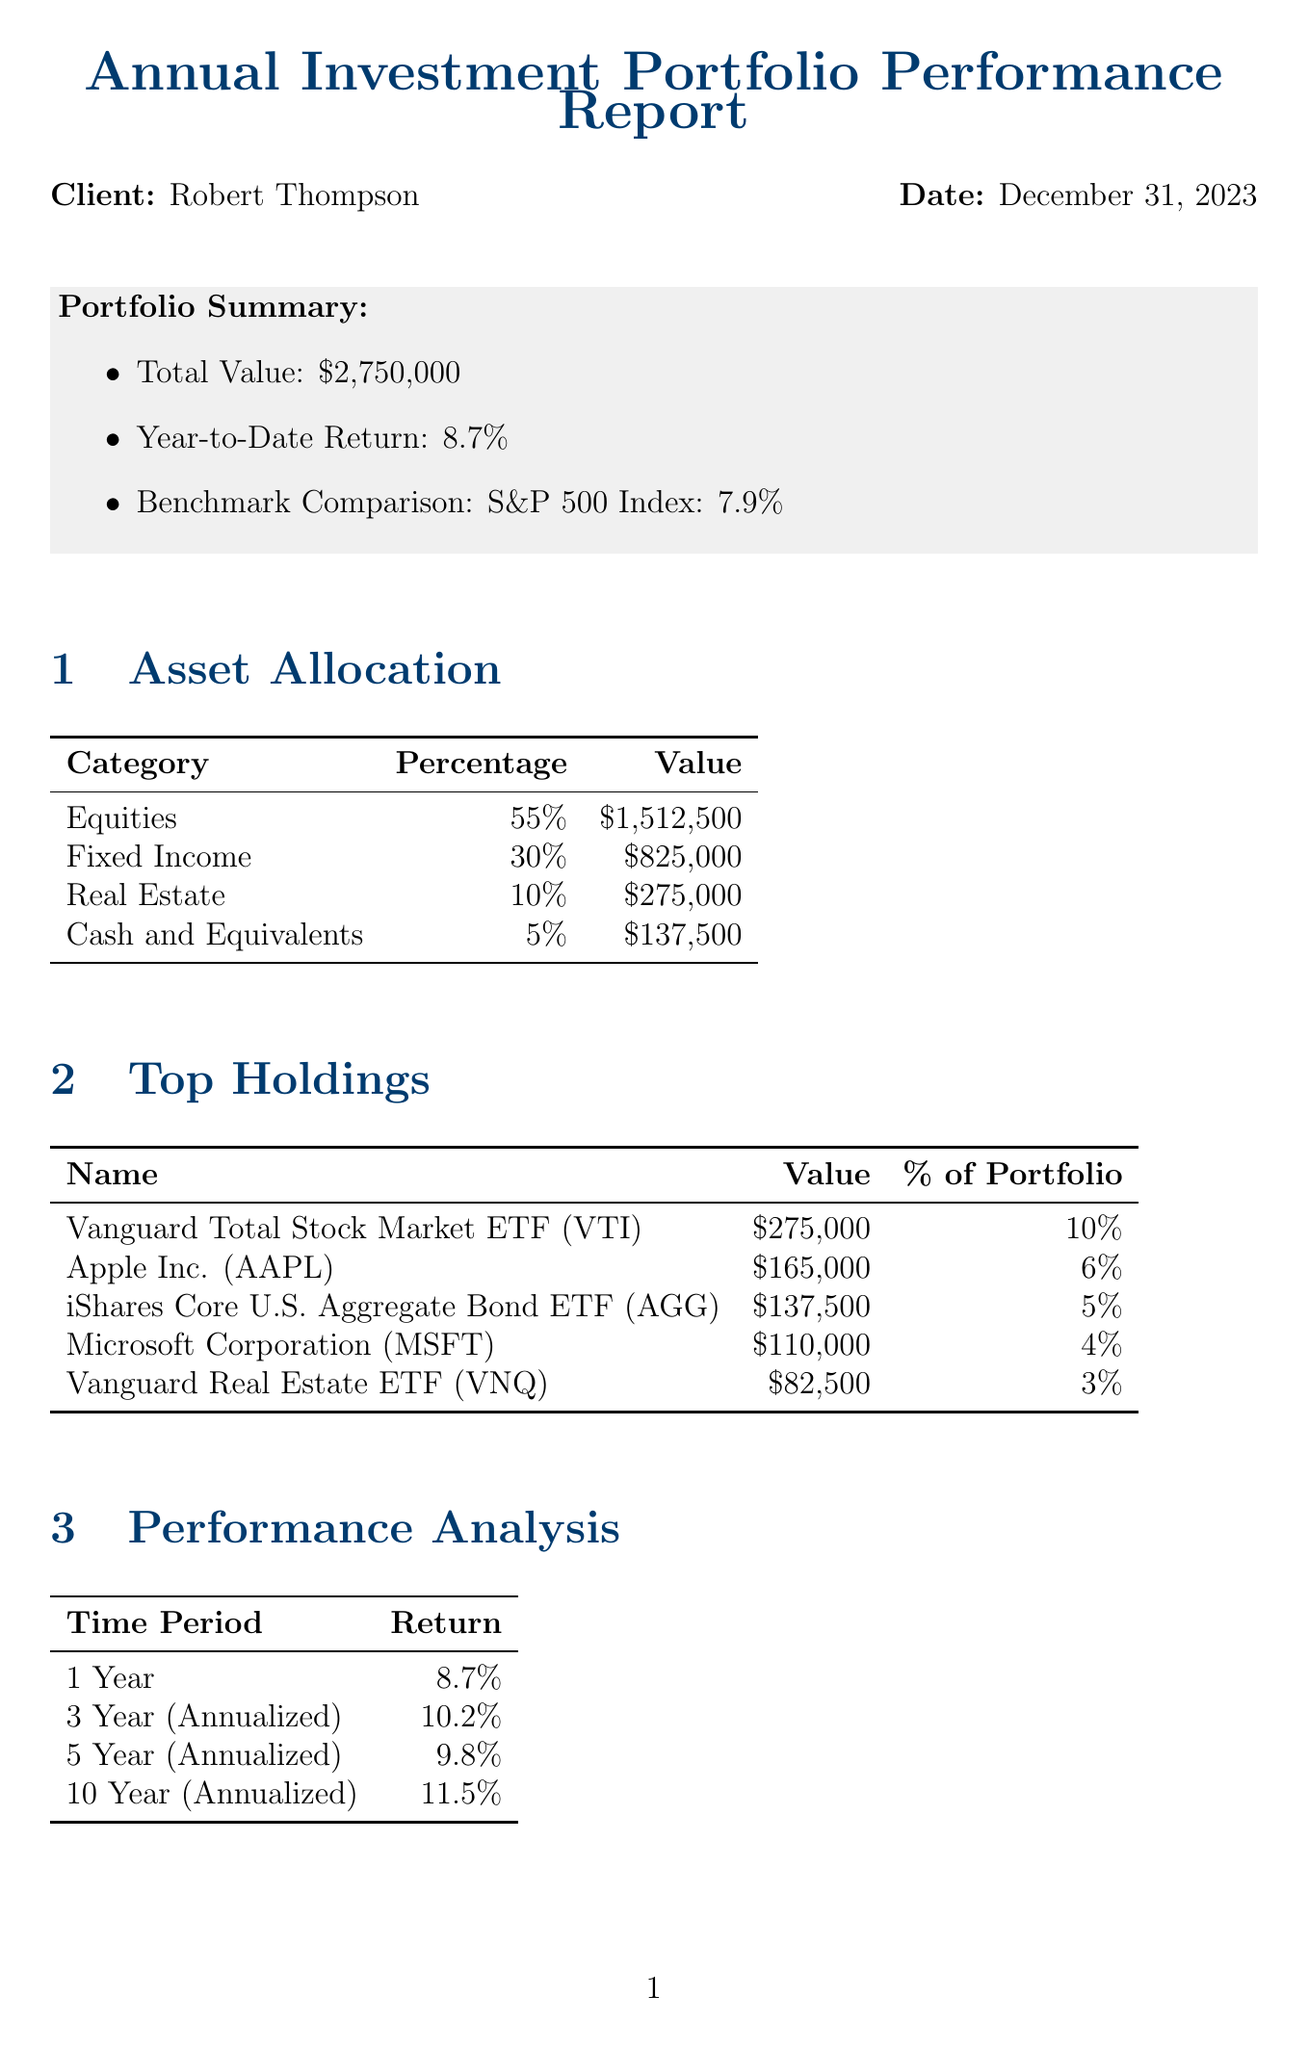what is the total value of the portfolio? The total value of the portfolio is stated in the document's portfolio summary, which shows $2,750,000.
Answer: $2,750,000 what is the year-to-date return? The year-to-date return can be found in the portfolio summary section, which states 8.7%.
Answer: 8.7% who is the client of the report? The client's name is provided at the beginning of the document, which indicates Robert Thompson.
Answer: Robert Thompson what is the percentage allocated to Fixed Income? The asset allocation table provides the percentage of each category, showing Fixed Income at 30%.
Answer: 30% how does the portfolio's one-year return compare to the benchmark? The one-year return of the portfolio is mentioned as 8.7%, while the benchmark comparison with the S&P 500 Index is 7.9%, indicating that the portfolio outperformed the benchmark.
Answer: Outperformed what is the Sharpe Ratio of the portfolio? The risk metrics section contains information on the Sharpe Ratio, which is stated as 0.68.
Answer: 0.68 what is one of the proposed changes in the recommendations? The recommendations section lists proposed changes, one of which is to increase allocation to value stocks.
Answer: Increase allocation to value stocks what is the total annual income generated by the portfolio? The income generation section details total annual income, which amounts to $104,500.
Answer: $104,500 when is the next review date for the report? The next review date is found in the recommendations and outlook section, indicating June 30, 2024.
Answer: June 30, 2024 